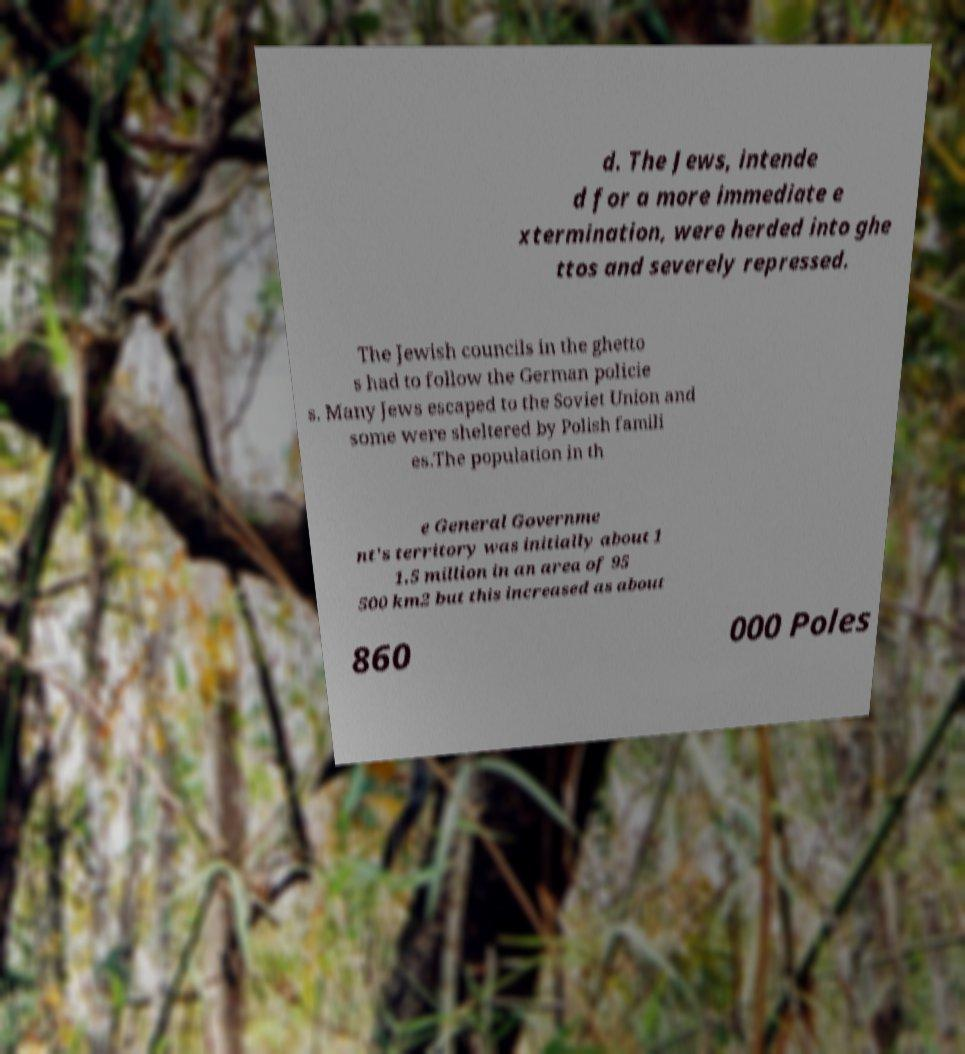There's text embedded in this image that I need extracted. Can you transcribe it verbatim? d. The Jews, intende d for a more immediate e xtermination, were herded into ghe ttos and severely repressed. The Jewish councils in the ghetto s had to follow the German policie s. Many Jews escaped to the Soviet Union and some were sheltered by Polish famili es.The population in th e General Governme nt's territory was initially about 1 1.5 million in an area of 95 500 km2 but this increased as about 860 000 Poles 